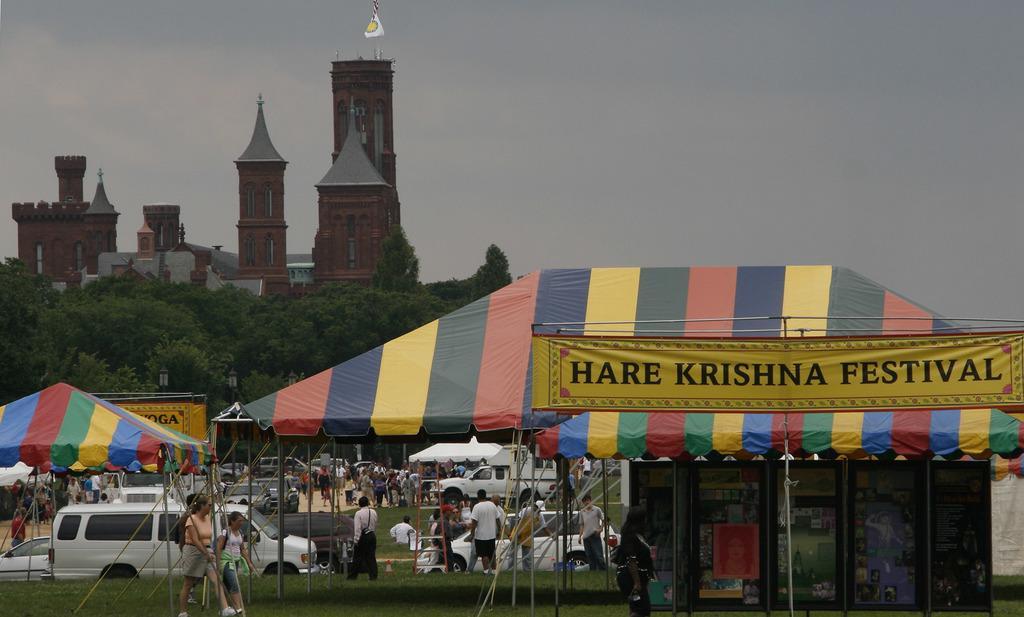Could you give a brief overview of what you see in this image? This picture is clicked outside the city. Here, we see people walking under the colorful tent. We even see stalls under the tent. Behind that, we see many people walking on the road. We even see cars parked on the road. On the right corner of the picture, we see a banner on which "HARE KRISHNA FESTIVAL" is written. There are many buildings and trees in the background. We even see a white color flag. At the top of the picture, we see the sky and at the bottom of the picture, we see grass. 